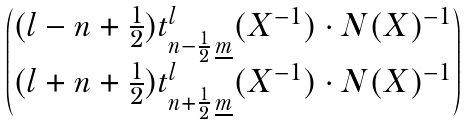<formula> <loc_0><loc_0><loc_500><loc_500>\begin{pmatrix} ( l - n + \frac { 1 } { 2 } ) t ^ { l } _ { n - \frac { 1 } { 2 } \, \underline { m } } ( X ^ { - 1 } ) \cdot N ( X ) ^ { - 1 } \\ ( l + n + \frac { 1 } { 2 } ) t ^ { l } _ { n + \frac { 1 } { 2 } \, \underline { m } } ( X ^ { - 1 } ) \cdot N ( X ) ^ { - 1 } \end{pmatrix}</formula> 